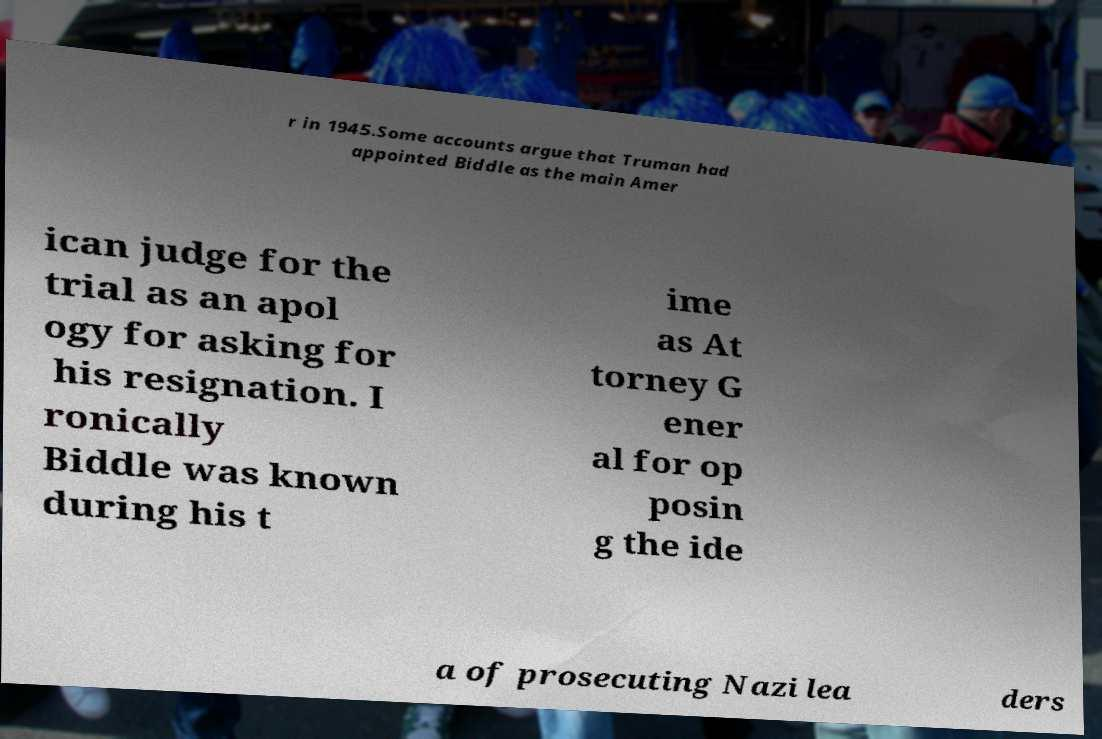Can you accurately transcribe the text from the provided image for me? r in 1945.Some accounts argue that Truman had appointed Biddle as the main Amer ican judge for the trial as an apol ogy for asking for his resignation. I ronically Biddle was known during his t ime as At torney G ener al for op posin g the ide a of prosecuting Nazi lea ders 